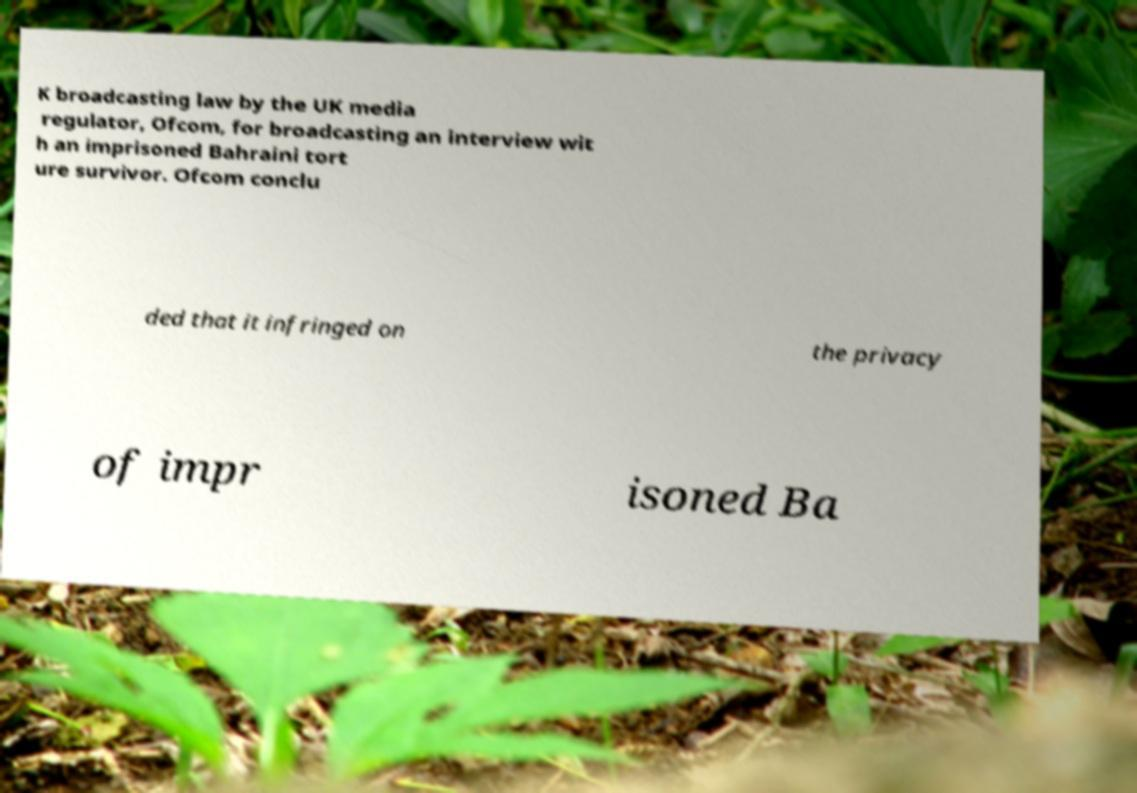Please read and relay the text visible in this image. What does it say? K broadcasting law by the UK media regulator, Ofcom, for broadcasting an interview wit h an imprisoned Bahraini tort ure survivor. Ofcom conclu ded that it infringed on the privacy of impr isoned Ba 